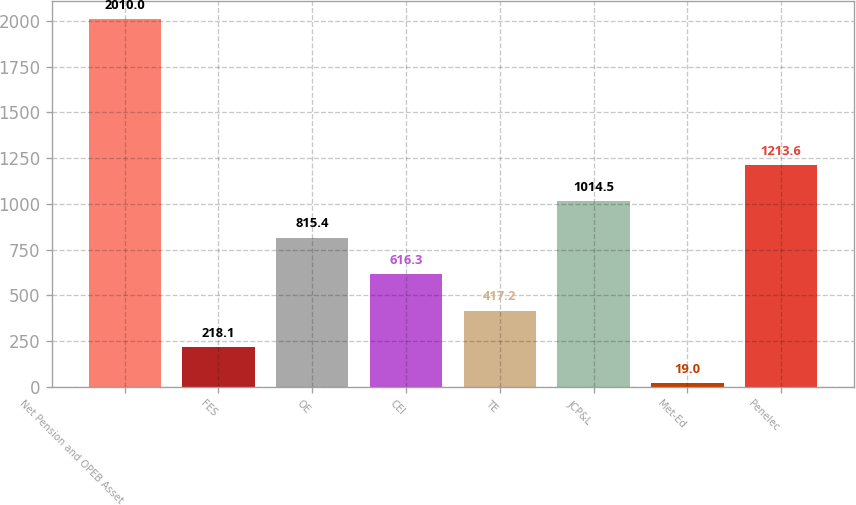Convert chart. <chart><loc_0><loc_0><loc_500><loc_500><bar_chart><fcel>Net Pension and OPEB Asset<fcel>FES<fcel>OE<fcel>CEI<fcel>TE<fcel>JCP&L<fcel>Met-Ed<fcel>Penelec<nl><fcel>2010<fcel>218.1<fcel>815.4<fcel>616.3<fcel>417.2<fcel>1014.5<fcel>19<fcel>1213.6<nl></chart> 